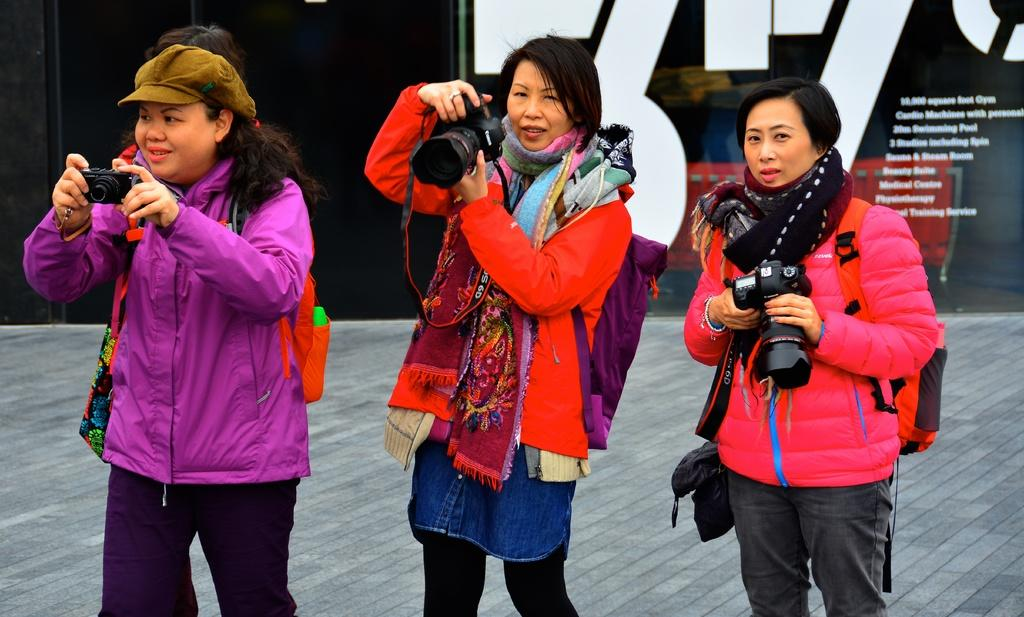How many people are in the image? There are three ladies in the image. What are the ladies holding in the image? The ladies are holding a camera. What shape is the sidewalk in the image? There is no sidewalk present in the image; it only shows three ladies holding a camera. 